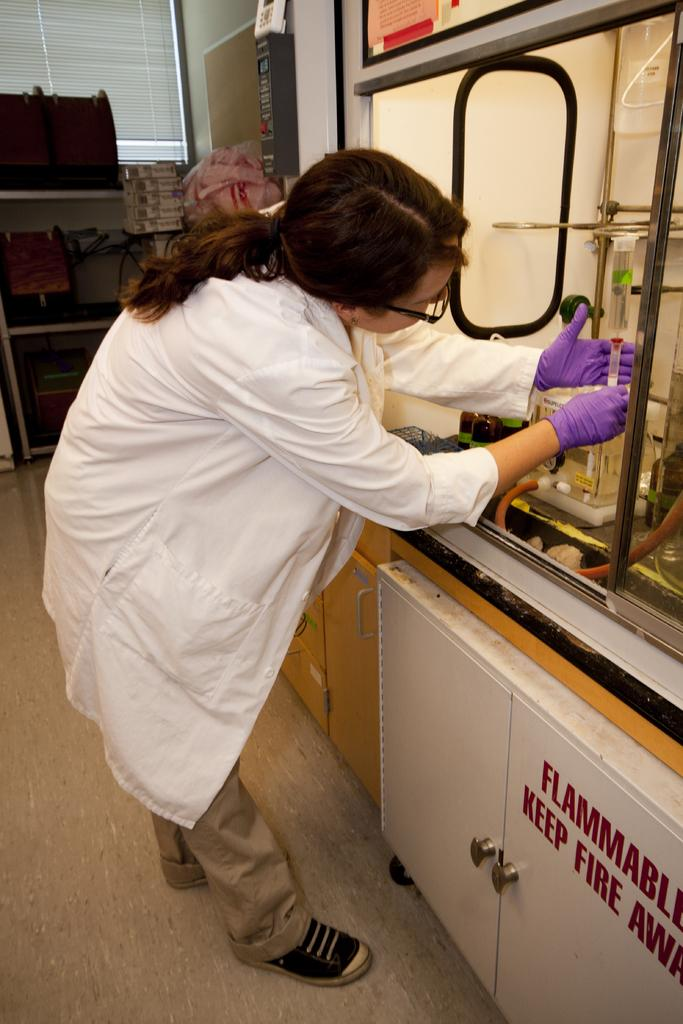<image>
Summarize the visual content of the image. A scientist works in a case labeled with FLAMMABLE KEEP FIRE AWAY. 